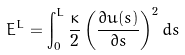<formula> <loc_0><loc_0><loc_500><loc_500>E ^ { L } = \int _ { 0 } ^ { L } \frac { \kappa } { 2 } \left ( \frac { \partial u ( s ) } { \partial s } \right ) ^ { 2 } d s</formula> 